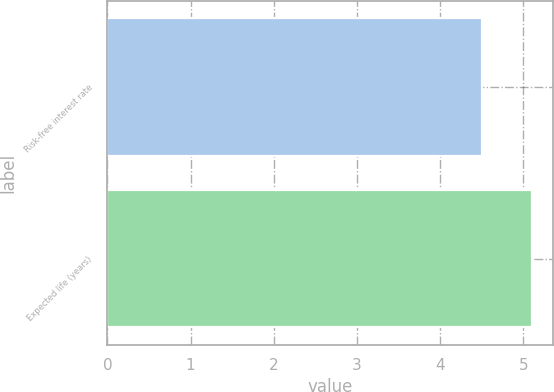<chart> <loc_0><loc_0><loc_500><loc_500><bar_chart><fcel>Risk-free interest rate<fcel>Expected life (years)<nl><fcel>4.5<fcel>5.1<nl></chart> 